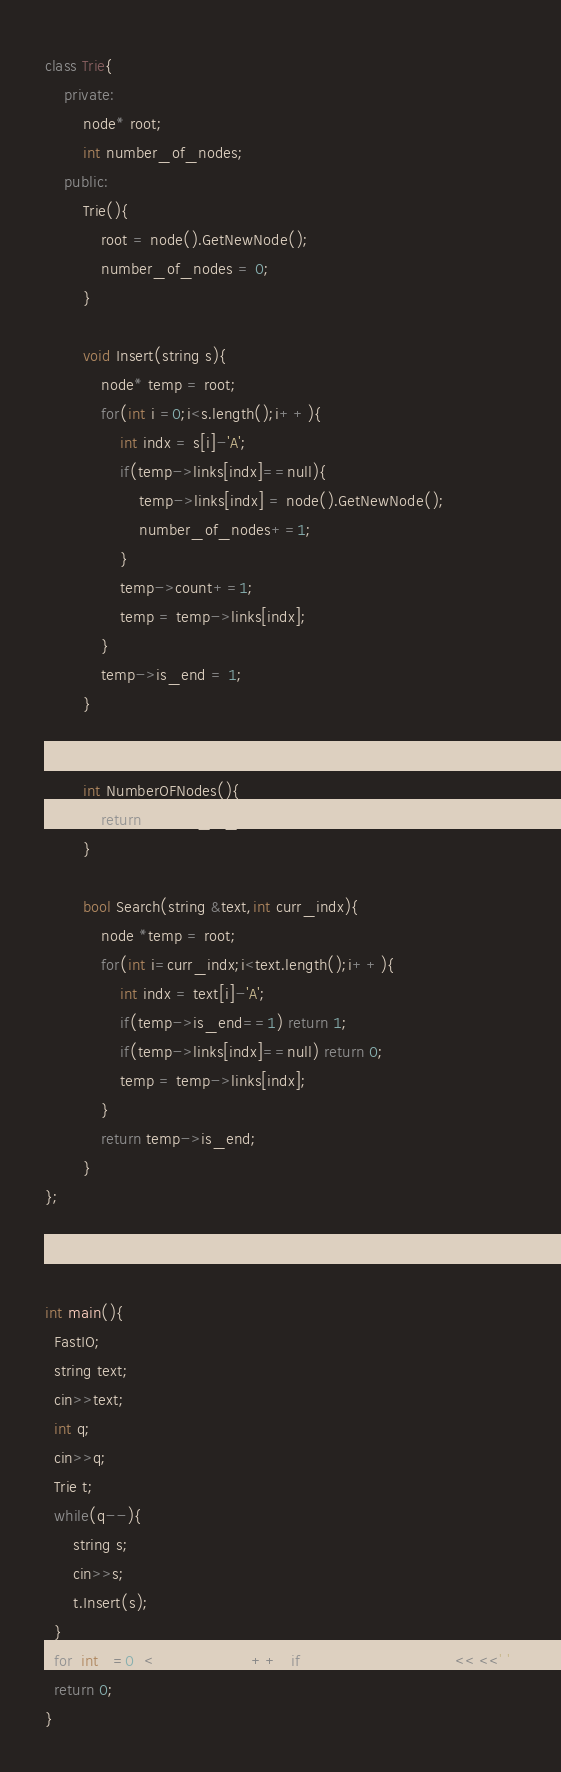Convert code to text. <code><loc_0><loc_0><loc_500><loc_500><_C++_>class Trie{
    private:
        node* root;
        int number_of_nodes;
    public:
        Trie(){
            root = node().GetNewNode();
            number_of_nodes = 0;
        }

        void Insert(string s){
            node* temp = root;
            for(int i =0;i<s.length();i++){
                int indx = s[i]-'A';
                if(temp->links[indx]==null){
                    temp->links[indx] = node().GetNewNode();
                    number_of_nodes+=1;
                }
                temp->count+=1;
                temp = temp->links[indx];
            }
            temp->is_end = 1;
        }

        
        int NumberOFNodes(){
            return number_of_nodes;
        }

        bool Search(string &text,int curr_indx){
            node *temp = root;
            for(int i=curr_indx;i<text.length();i++){
                int indx = text[i]-'A';
				if(temp->is_end==1) return 1;
				if(temp->links[indx]==null) return 0;
				temp = temp->links[indx];
            }
            return temp->is_end;
        }
};



int main(){
  FastIO;
  string text;
  cin>>text;
  int q;
  cin>>q;
  Trie t;
  while(q--){
	  string s;
	  cin>>s;
	  t.Insert(s);
  }
  for(int i =0;i<text.length();i++) if(t.Search(text,i)) cout<<i<<' ';
  return 0;
} 
</code> 